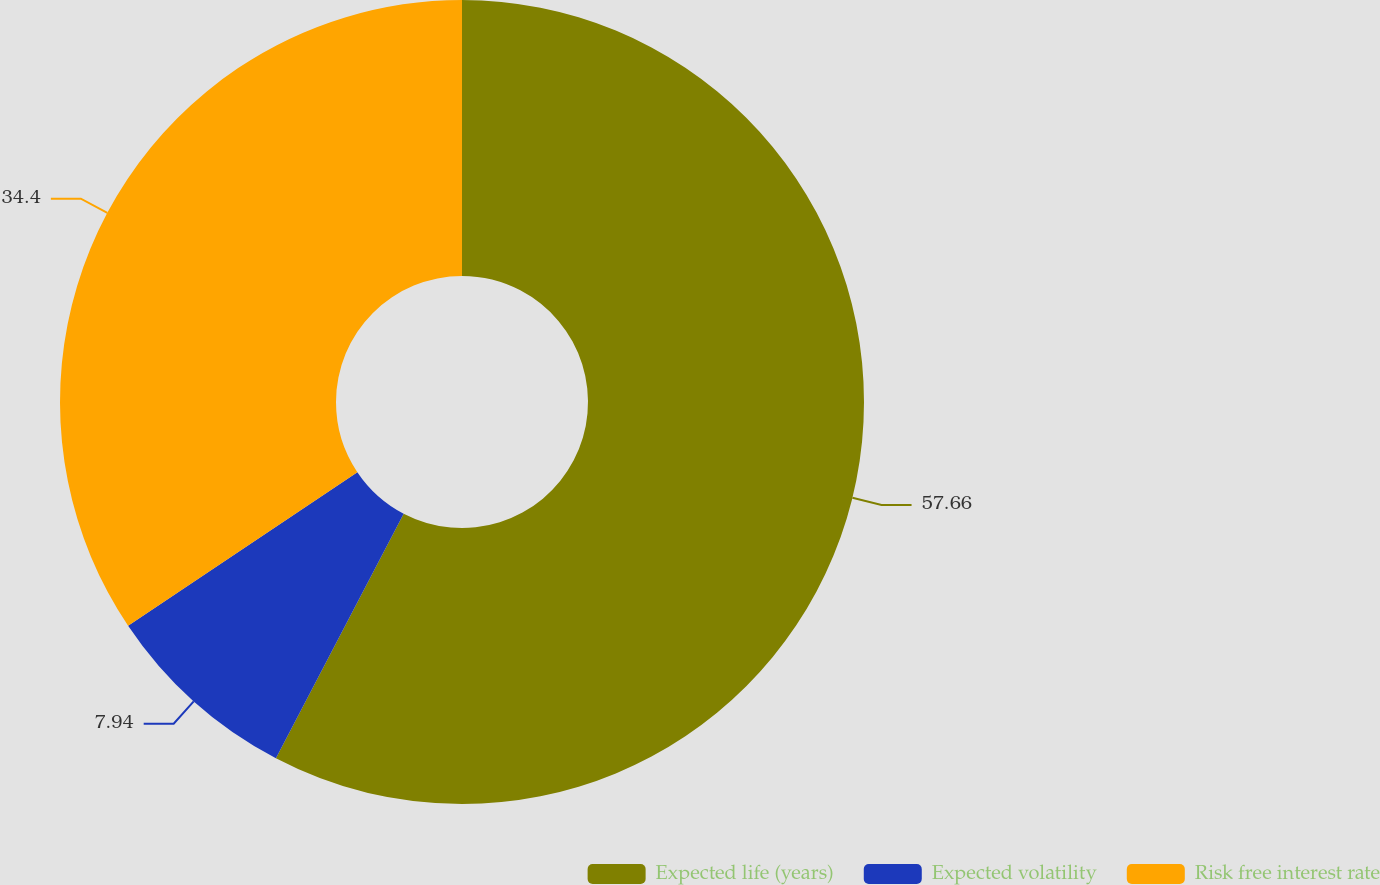Convert chart to OTSL. <chart><loc_0><loc_0><loc_500><loc_500><pie_chart><fcel>Expected life (years)<fcel>Expected volatility<fcel>Risk free interest rate<nl><fcel>57.66%<fcel>7.94%<fcel>34.4%<nl></chart> 